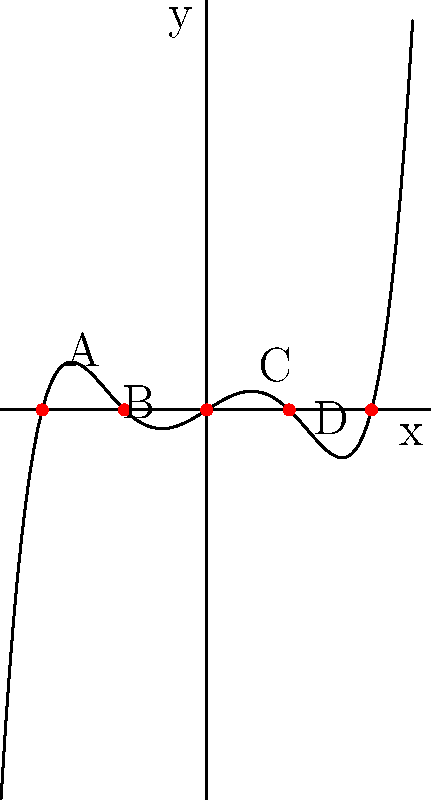The graph of a polynomial function resembles a menorah, a symbol of great importance in Jewish tradition. This polynomial has 5 roots and 4 turning points. If we label the turning points from left to right as A, B, C, and D, which of these points represent local maxima? To determine which points represent local maxima, we need to analyze the behavior of the function around each turning point:

1. Point A: The curve goes from decreasing to increasing as we move through this point from left to right. This makes point A a local minimum.

2. Point B: The curve goes from increasing to decreasing as we move through this point from left to right. This makes point B a local maximum.

3. Point C: The curve goes from decreasing to increasing as we move through this point from left to right. This makes point C a local minimum.

4. Point D: The curve goes from increasing to decreasing as we move through this point from left to right. This makes point D a local maximum.

Therefore, points B and D represent local maxima.

This shape is reminiscent of a menorah, with the central branch (at x = 0) being the tallest, and symmetric branches on either side, much like the structure of the traditional nine-branched Hanukkah menorah.
Answer: B and D 